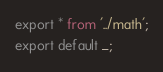Convert code to text. <code><loc_0><loc_0><loc_500><loc_500><_TypeScript_>export * from '../math';
export default _;</code> 